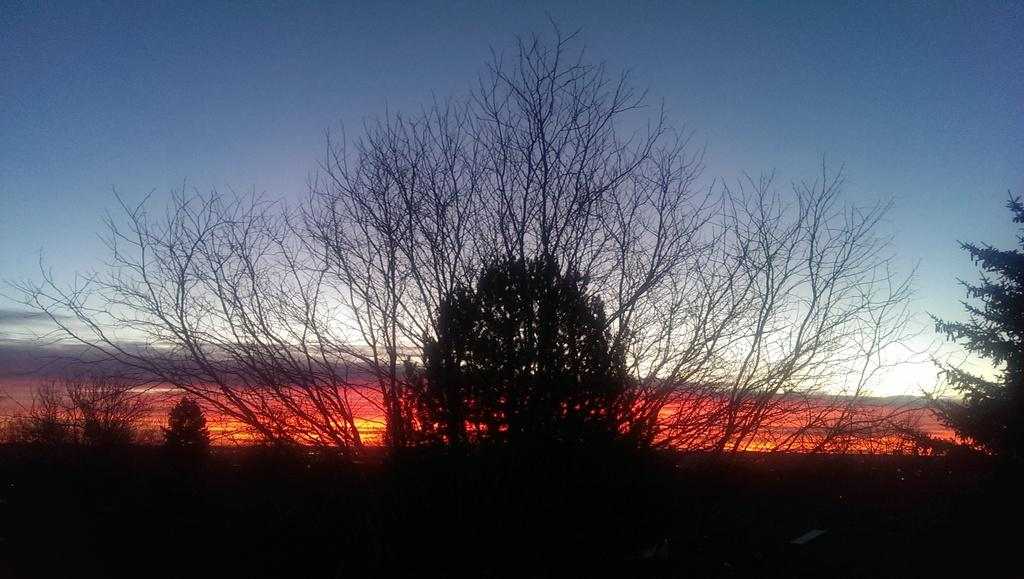What type of vegetation can be seen in the image? There are trees in the image. What part of the natural environment is visible in the image? The sky is visible in the background of the image. What type of punishment is being given to the orange in the image? There is no orange present in the image, and therefore no punishment can be observed. 